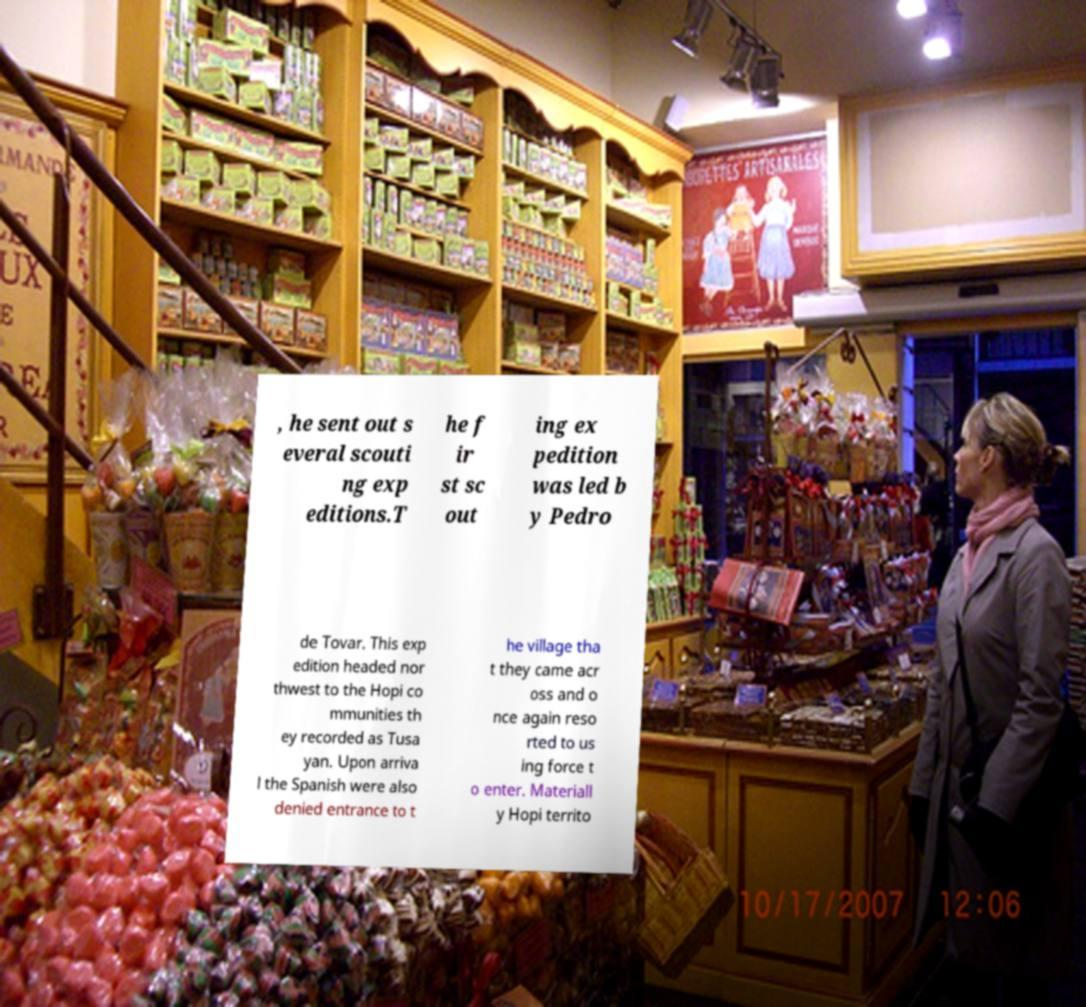Please identify and transcribe the text found in this image. , he sent out s everal scouti ng exp editions.T he f ir st sc out ing ex pedition was led b y Pedro de Tovar. This exp edition headed nor thwest to the Hopi co mmunities th ey recorded as Tusa yan. Upon arriva l the Spanish were also denied entrance to t he village tha t they came acr oss and o nce again reso rted to us ing force t o enter. Materiall y Hopi territo 